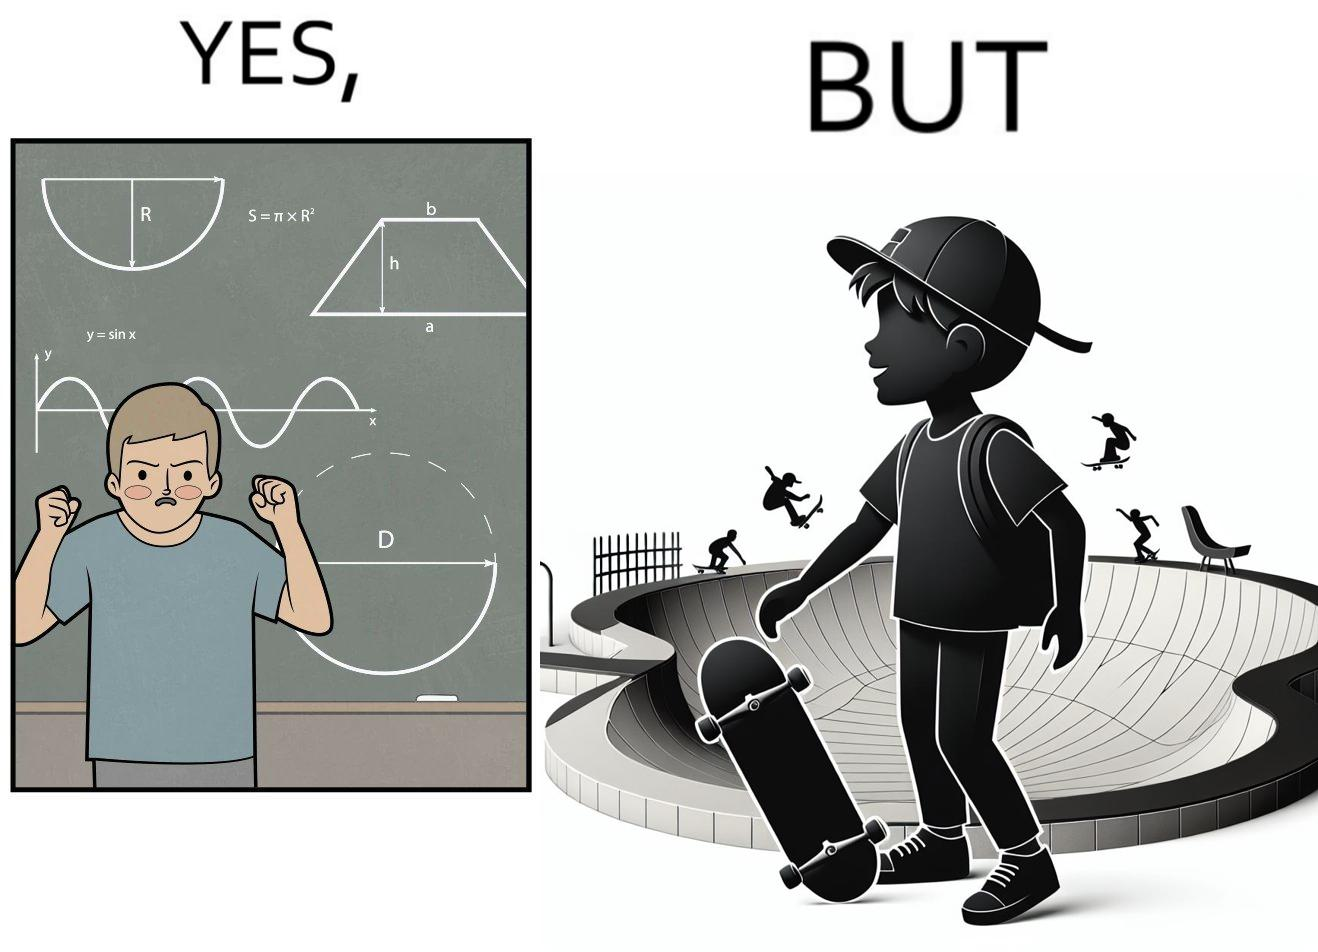Describe what you see in this image. The image is ironical beaucse while the boy does not enjoy studying mathematics and different geometric shapes like semi circle and trapezoid and graphs of trigonometric equations like that of a sine wave, he enjoys skateboarding on surfaces and bowls that are built based on the said geometric shapes and graphs of trigonometric equations. 